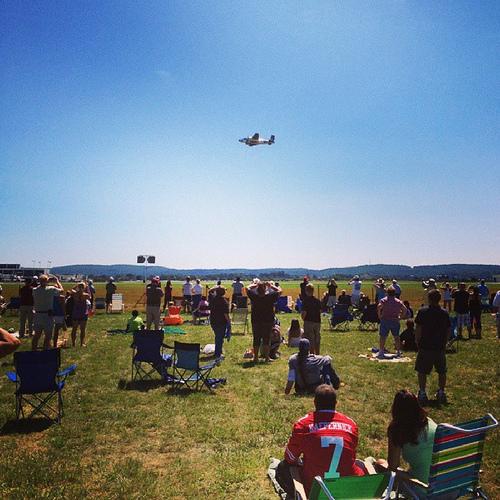In which part is the blue chair, the top or the bottom? The blue chair is positioned at the bottom of the image. 